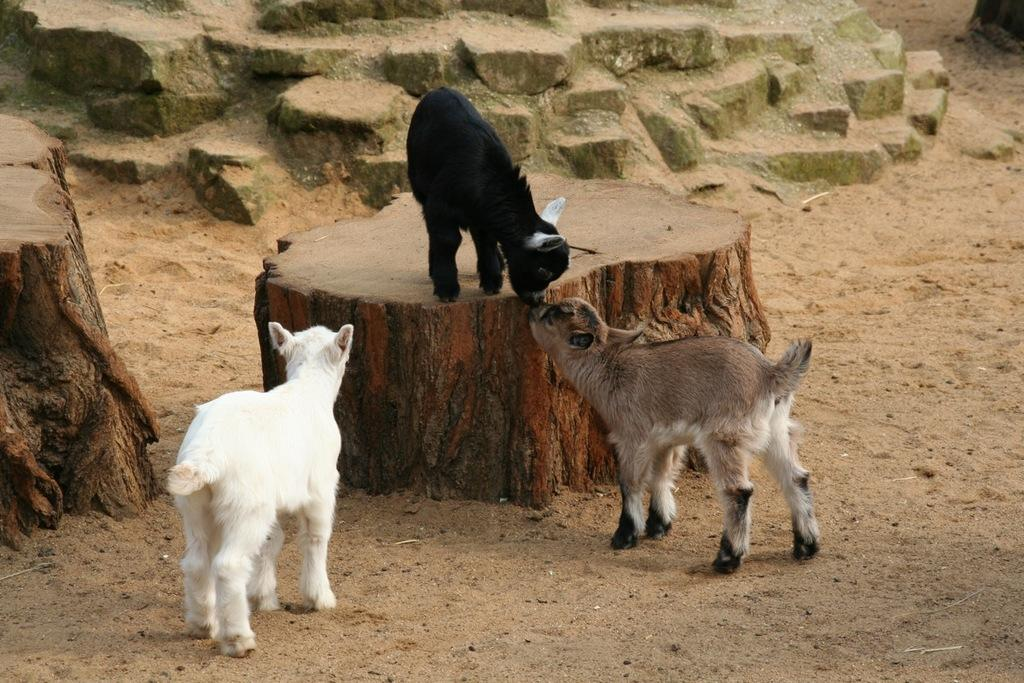What animals can be seen in the image? There are goats in the image. What type of material is present in the image? There are wooden logs in the image. What is the surface at the bottom of the image? There is sand at the bottom of the image. What can be seen at the top of the image? There are stones visible at the top of the image. What type of joke is being told by the goats in the image? There is no indication in the image that the goats are telling a joke, as they are not depicted as engaging in any verbal communication. 